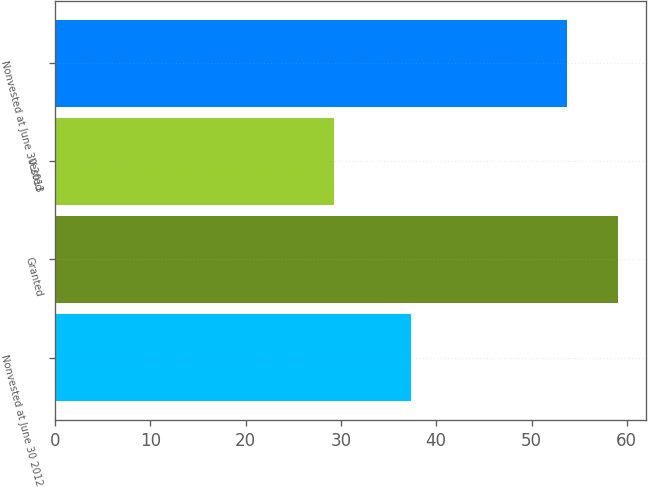Convert chart. <chart><loc_0><loc_0><loc_500><loc_500><bar_chart><fcel>Nonvested at June 30 2012<fcel>Granted<fcel>Vested<fcel>Nonvested at June 30 2013<nl><fcel>37.31<fcel>59.09<fcel>29.31<fcel>53.73<nl></chart> 